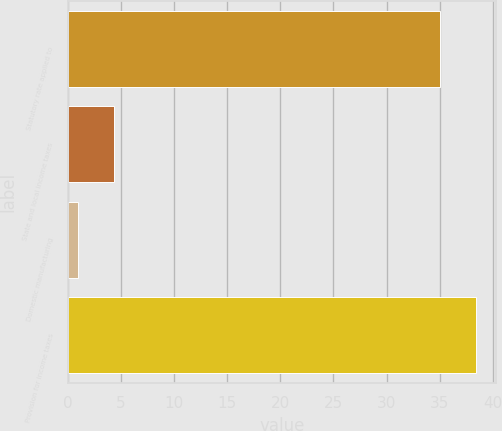Convert chart to OTSL. <chart><loc_0><loc_0><loc_500><loc_500><bar_chart><fcel>Statutory rate applied to<fcel>State and local income taxes<fcel>Domestic manufacturing<fcel>Provision for income taxes<nl><fcel>35<fcel>4.4<fcel>1<fcel>38.4<nl></chart> 